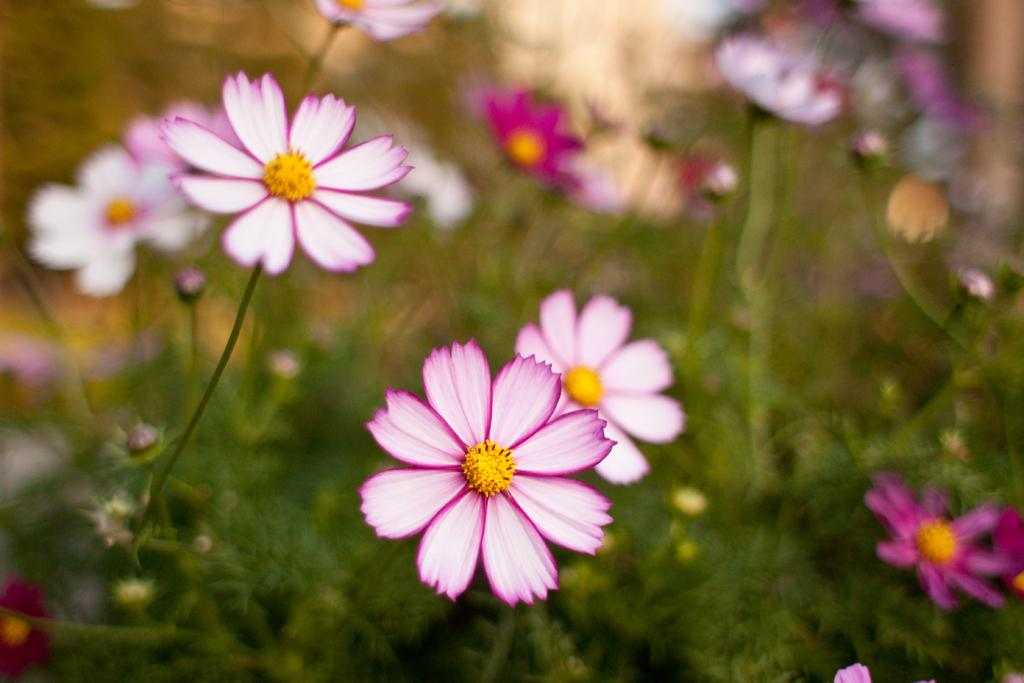What is present in the image? There are flowers in the image. Can you describe the background of the image? The background of the image is blurred. How many ducks can be seen in the garden in the image? There are no ducks or gardens present in the image; it only features flowers with a blurred background. 